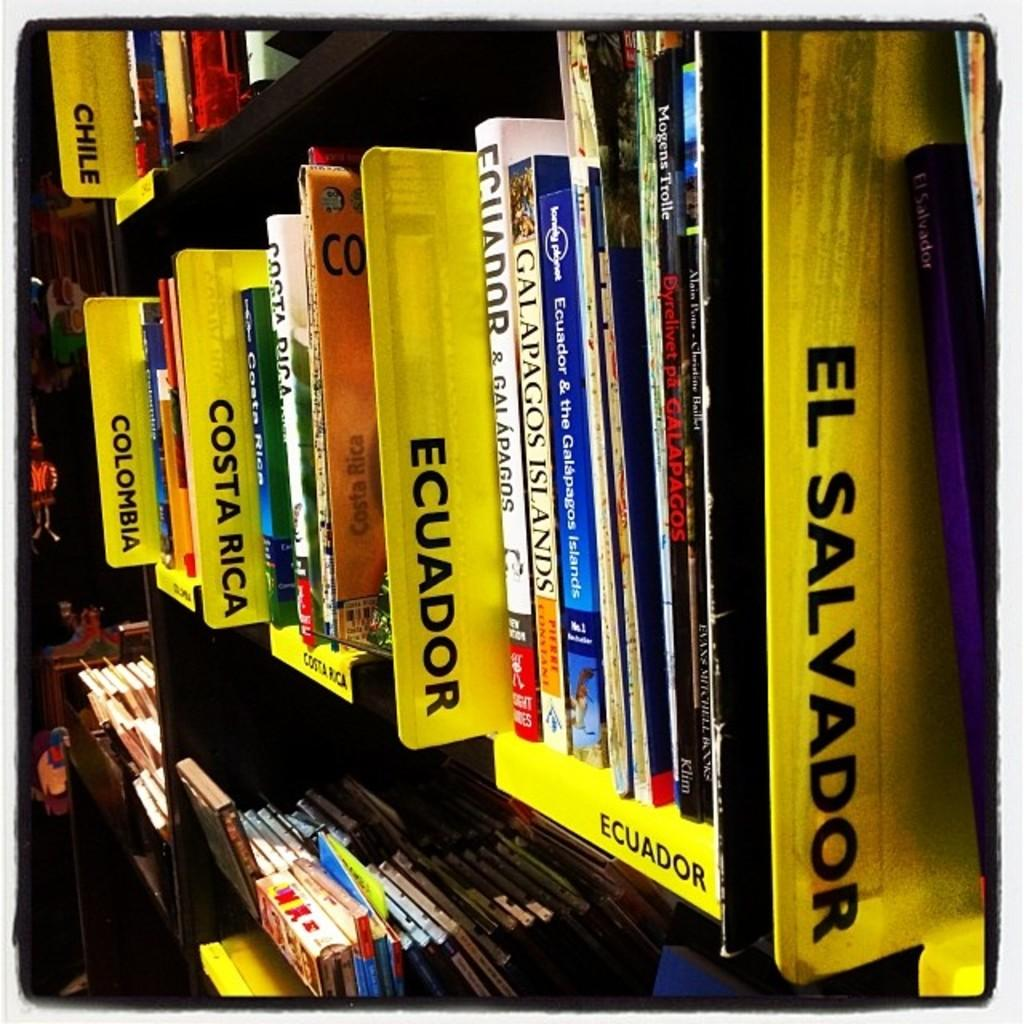Provide a one-sentence caption for the provided image. A collection of books are organized by country. 